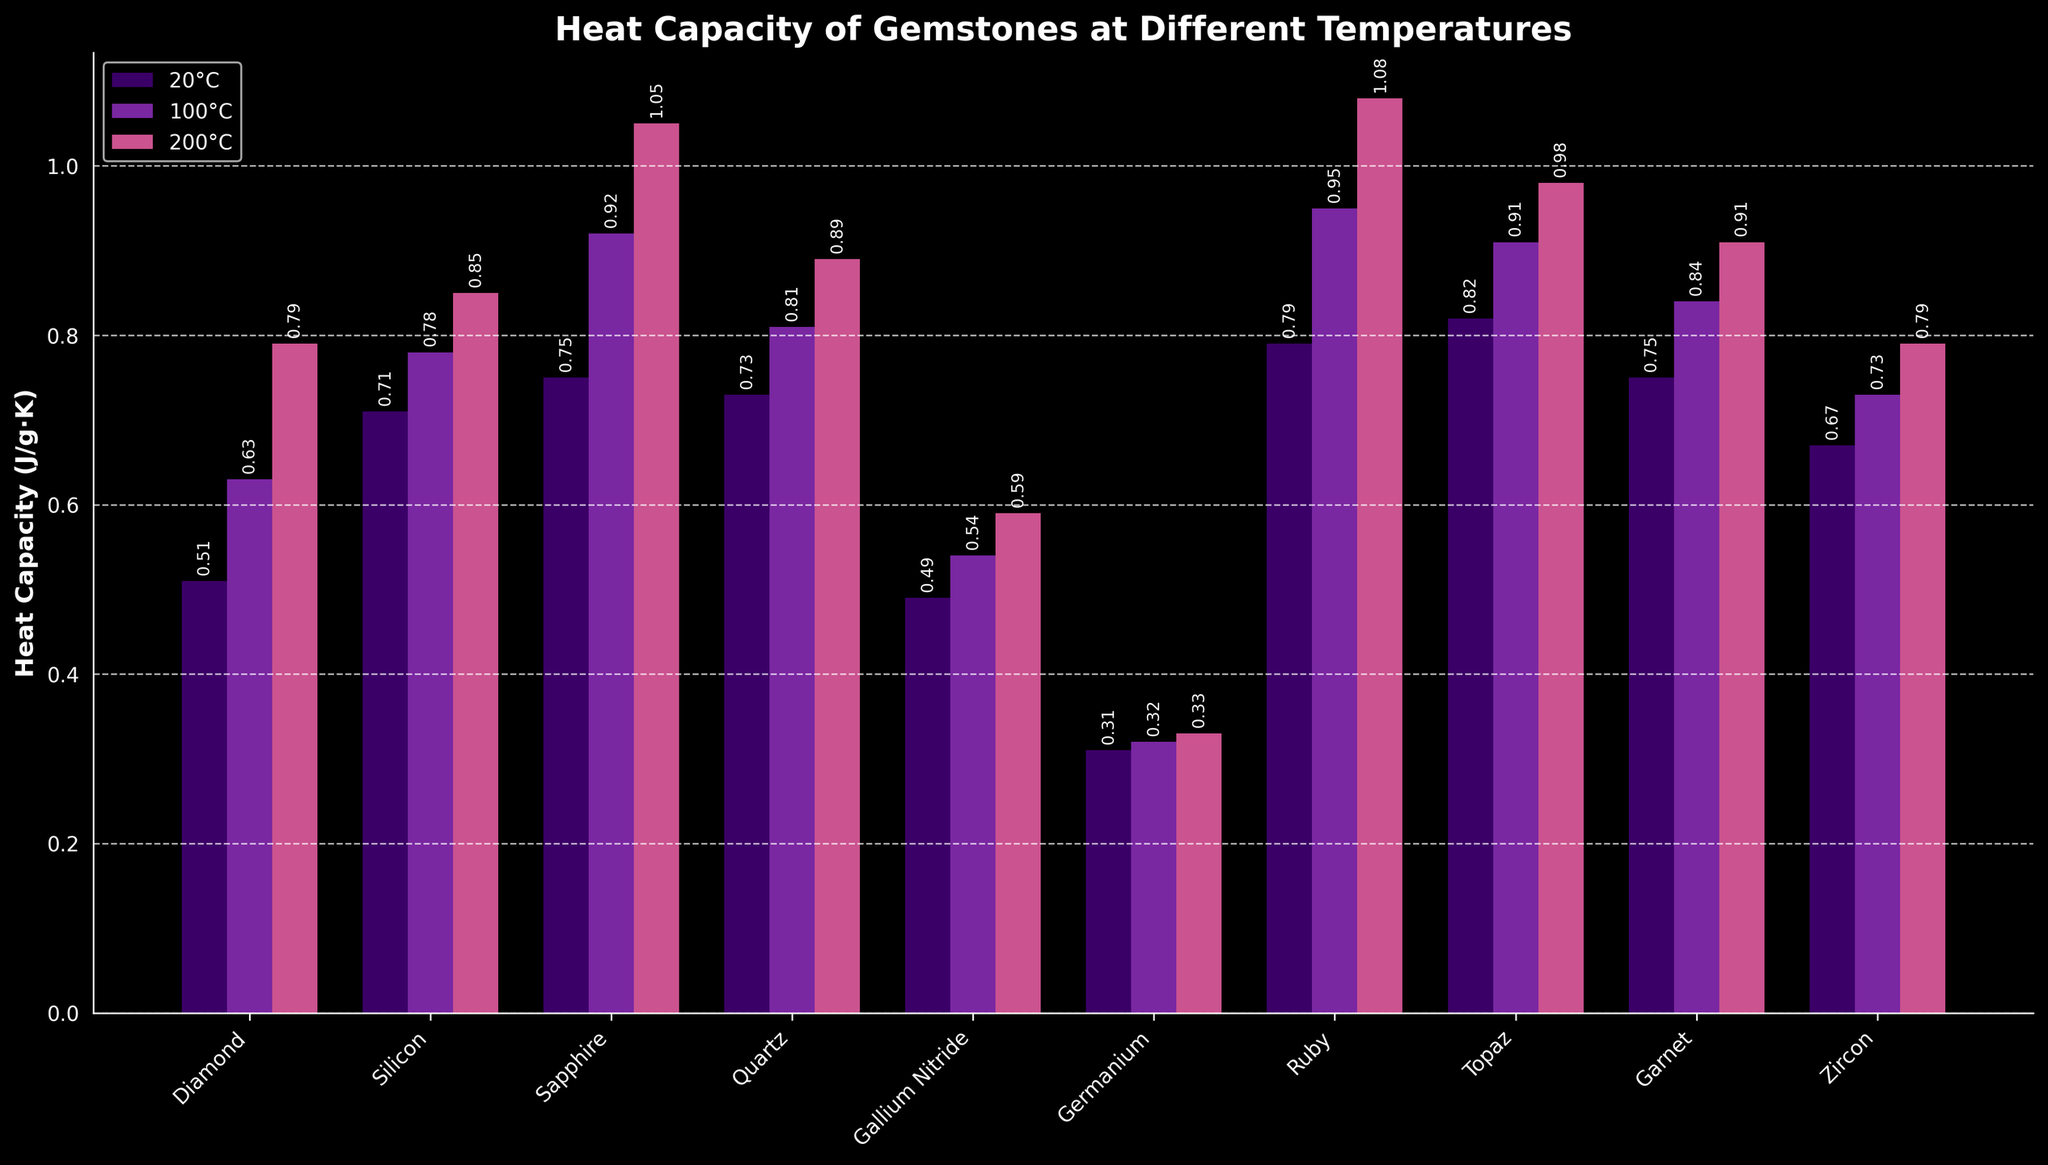What is the heat capacity of Ruby at 20°C and 200°C? Ruby has a heat capacity of 0.79 J/g·K at 20°C (from the leftmost bar cluster for each gemstone, find the bar labeled 20°C for Ruby) and 1.08 J/g·K at 200°C (from the rightmost bar cluster for each gemstone, find the corresponding bar for Ruby).
Answer: 0.79 J/g·K and 1.08 J/g·K Which gemstone has the lowest heat capacity at 100°C? To determine this, look at the second set of bars from the left for each gemstone (labeled 100°C). The bar with the smallest height corresponds to Germanium.
Answer: Germanium Which gemstone shows the greatest increase in heat capacity from 20°C to 200°C? Calculate the increase for each gemstone by subtracting the heat capacity at 20°C from that at 200°C. Ruby has the greatest increase (1.08 - 0.79 = 0.29 J/g·K).
Answer: Ruby How does the heat capacity of Diamond at 100°C compare to that of Sapphire at 100°C? Locate the bars for Diamond and Sapphire both labeled at 100°C. Diamond's bar is at 0.63 J/g·K while Sapphire's is at 0.92 J/g·K. Hence, Diamond has a lower heat capacity than Sapphire at 100°C.
Answer: Diamond's is lower What is the combined heat capacity of Quartz and Zircon at 200°C? Sum the heat capacities of Quartz (0.89 J/g·K) and Zircon (0.79 J/g·K) at 200°C. The combined value is 0.89 + 0.79 = 1.68 J/g·K.
Answer: 1.68 J/g·K Which gemstone has the highest heat capacity at every temperature measured? Identify the highest bars in each set (20°C, 100°C, 200°C). Ruby has the highest bars at each temperature, indicating it has the highest heat capacity.
Answer: Ruby What is the average increase in heat capacity from 100°C to 200°C for Sapphire and Garnet? Calculate the increases individually for Sapphire (1.05 - 0.92 = 0.13 J/g·K) and Garnet (0.91 - 0.84 = 0.07 J/g·K), then find the average: (0.13 + 0.07) / 2 = 0.10 J/g·K.
Answer: 0.10 J/g·K Which gemstone has nearly the same heat capacity at 100°C and 200°C? Look for gemstones whose bars at 100°C and 200°C have very similar heights. Germanium fits this description, with values at 0.32 and 0.33 J/g·K respectively.
Answer: Germanium 